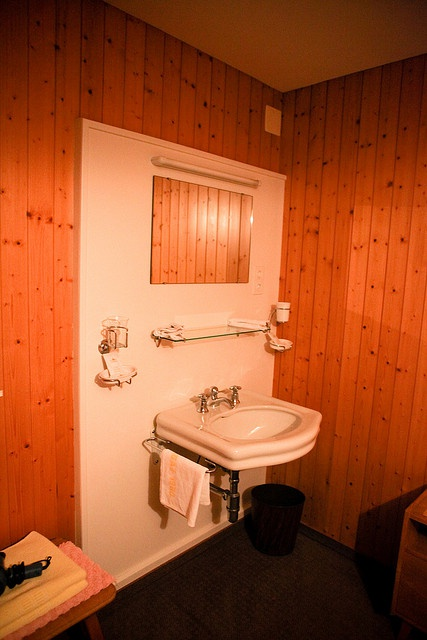Describe the objects in this image and their specific colors. I can see sink in black, tan, and brown tones, hair drier in black, maroon, brown, and red tones, cup in black, tan, and brown tones, and hair drier in black, salmon, tan, and red tones in this image. 